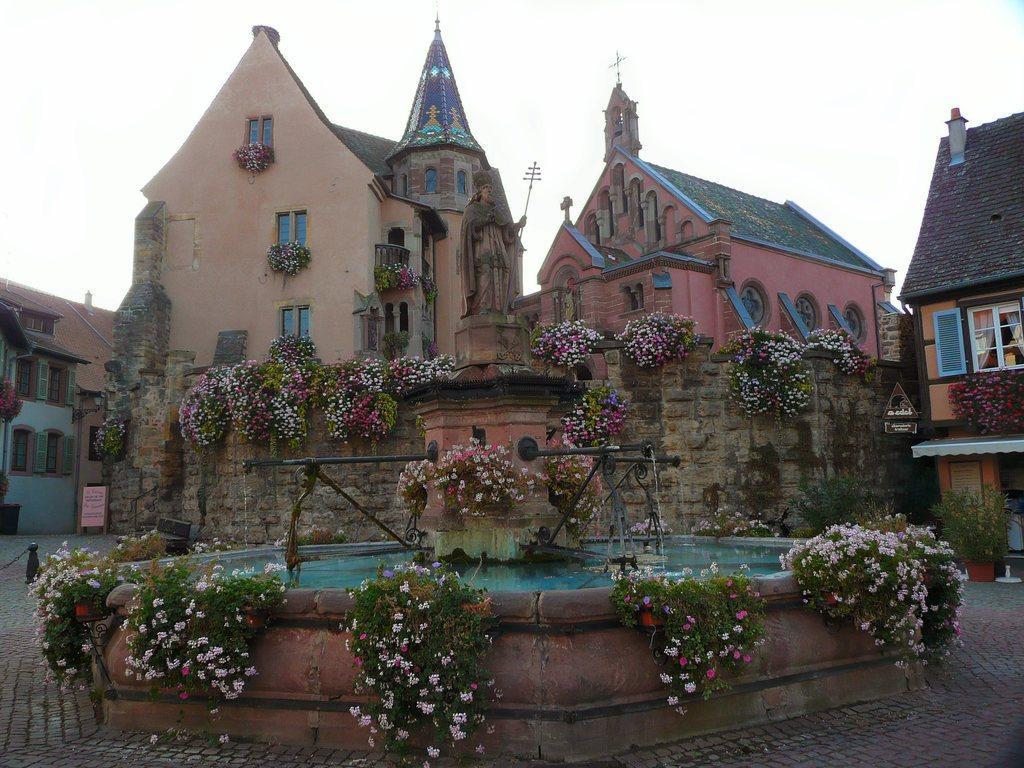Please provide a concise description of this image. In this image there is a pavement, in the middle there is a fountain and a statute that is decorated with plants, in the background there is a church and houses on that church there are plants and there is the sky. 